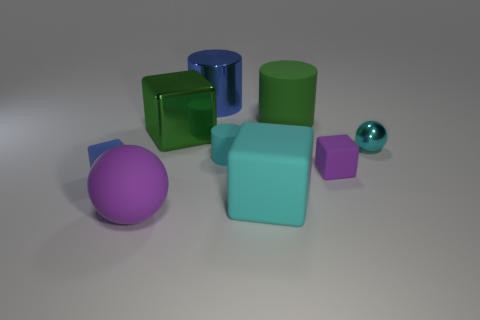Add 1 rubber objects. How many objects exist? 10 Subtract all cylinders. How many objects are left? 6 Add 4 purple balls. How many purple balls exist? 5 Subtract 0 brown cylinders. How many objects are left? 9 Subtract all green rubber cylinders. Subtract all cyan cylinders. How many objects are left? 7 Add 8 big cyan rubber cubes. How many big cyan rubber cubes are left? 9 